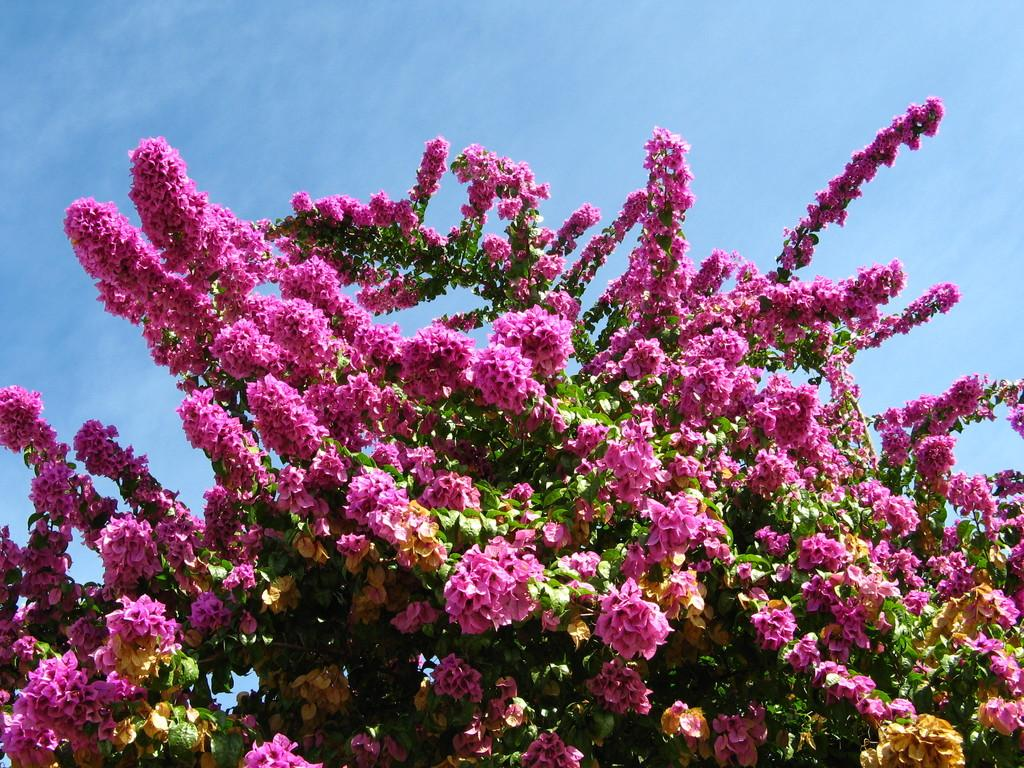What color are the flowers in the image? The flowers in the image are pink. What is located at the bottom of the image? There is a plant at the bottom of the image. What can be seen at the top of the image? The sky is visible at the top of the image. What is present in the sky? Clouds are present in the sky. What type of soup is being served in the image? There is no soup present in the image. How many stitches are visible on the flowers in the image? The flowers in the image are not stitched, so there are no stitches visible. 